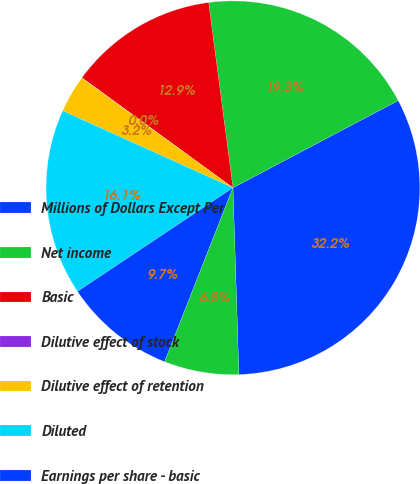Convert chart. <chart><loc_0><loc_0><loc_500><loc_500><pie_chart><fcel>Millions of Dollars Except Per<fcel>Net income<fcel>Basic<fcel>Dilutive effect of stock<fcel>Dilutive effect of retention<fcel>Diluted<fcel>Earnings per share - basic<fcel>Earnings per share - diluted<nl><fcel>32.22%<fcel>19.34%<fcel>12.9%<fcel>0.02%<fcel>3.24%<fcel>16.12%<fcel>9.68%<fcel>6.46%<nl></chart> 